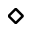<formula> <loc_0><loc_0><loc_500><loc_500>\diamond</formula> 